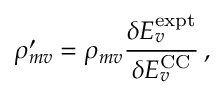Convert formula to latex. <formula><loc_0><loc_0><loc_500><loc_500>\rho _ { m v } ^ { \prime } = \rho _ { m v } \frac { \delta E _ { v } ^ { e x p t } } { \delta E _ { v } ^ { C C } } \, ,</formula> 